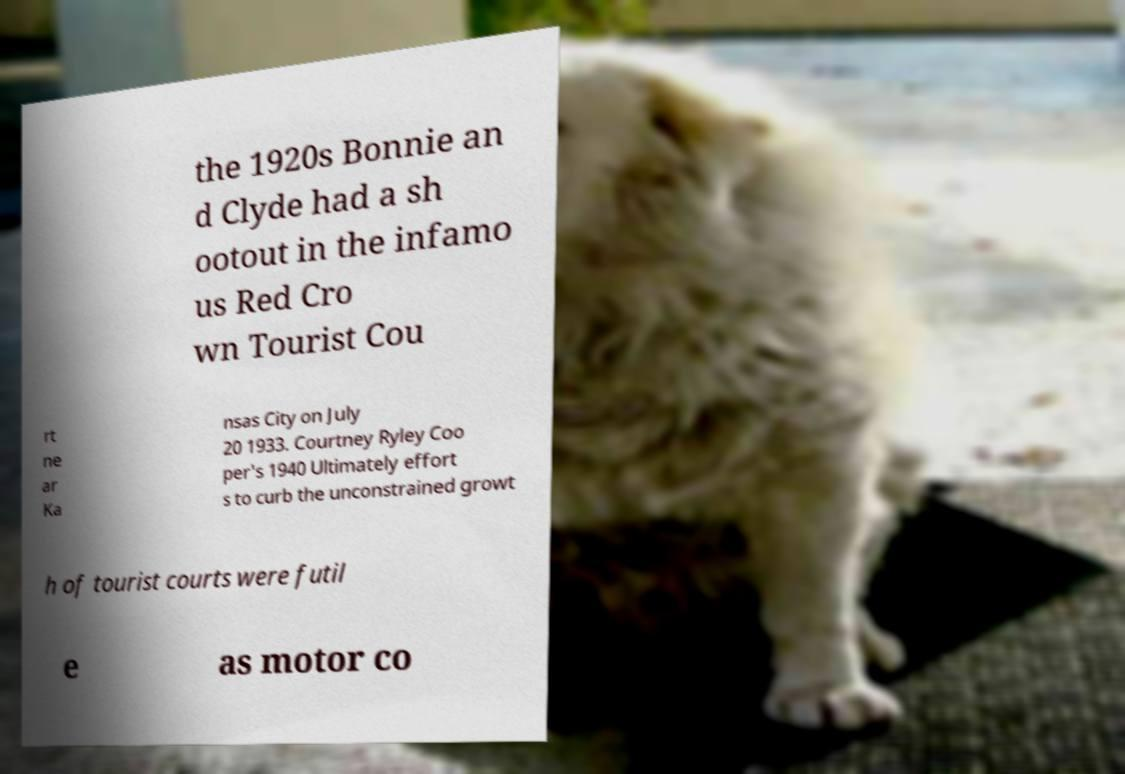I need the written content from this picture converted into text. Can you do that? the 1920s Bonnie an d Clyde had a sh ootout in the infamo us Red Cro wn Tourist Cou rt ne ar Ka nsas City on July 20 1933. Courtney Ryley Coo per's 1940 Ultimately effort s to curb the unconstrained growt h of tourist courts were futil e as motor co 